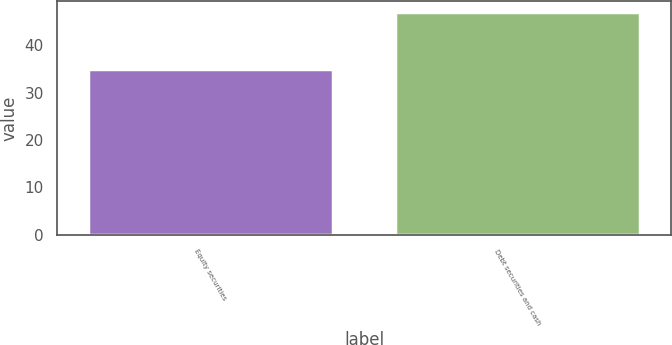Convert chart to OTSL. <chart><loc_0><loc_0><loc_500><loc_500><bar_chart><fcel>Equity securities<fcel>Debt securities and cash<nl><fcel>35<fcel>47<nl></chart> 